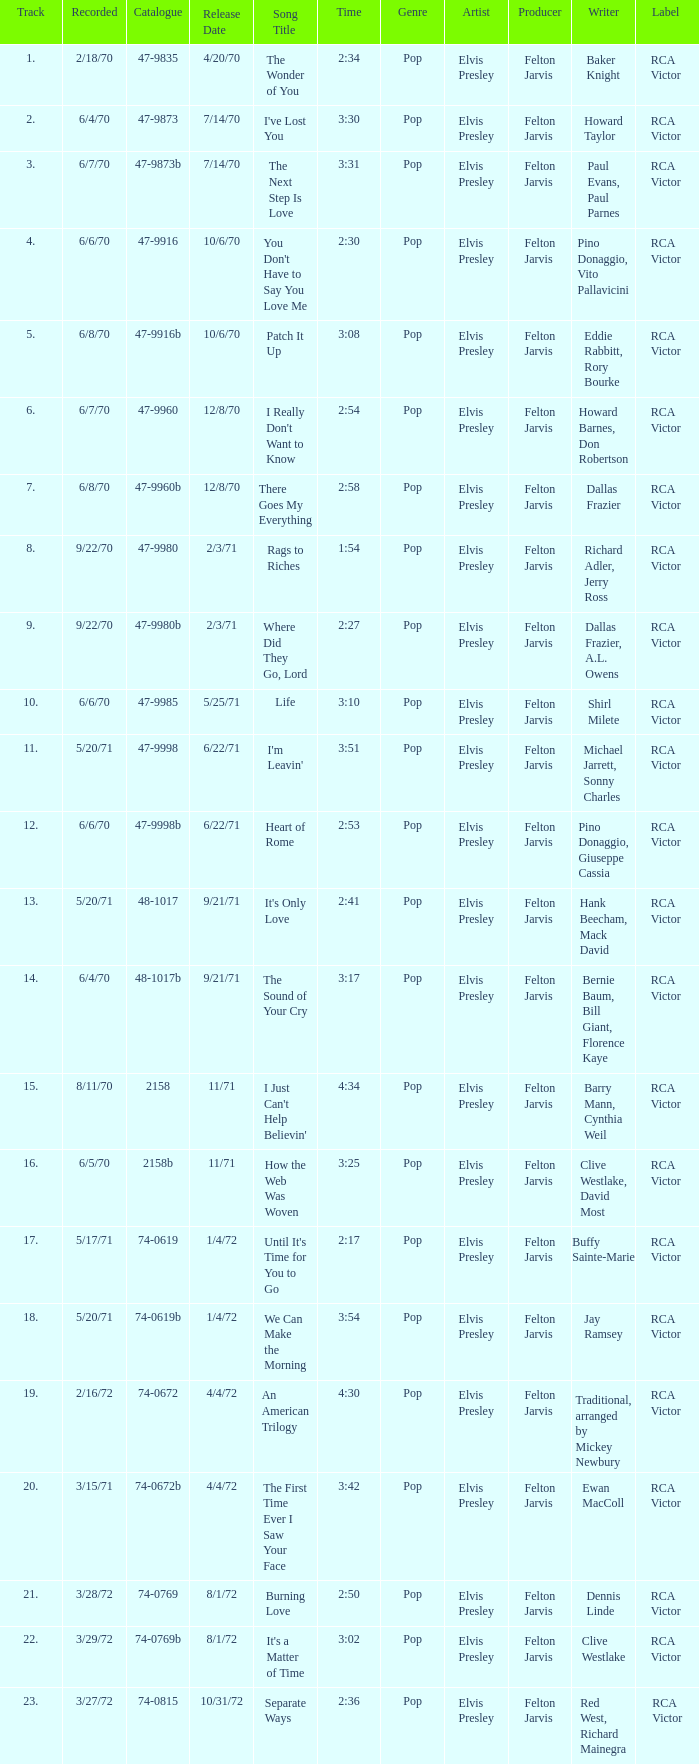What is Heart of Rome's catalogue number? 47-9998b. 